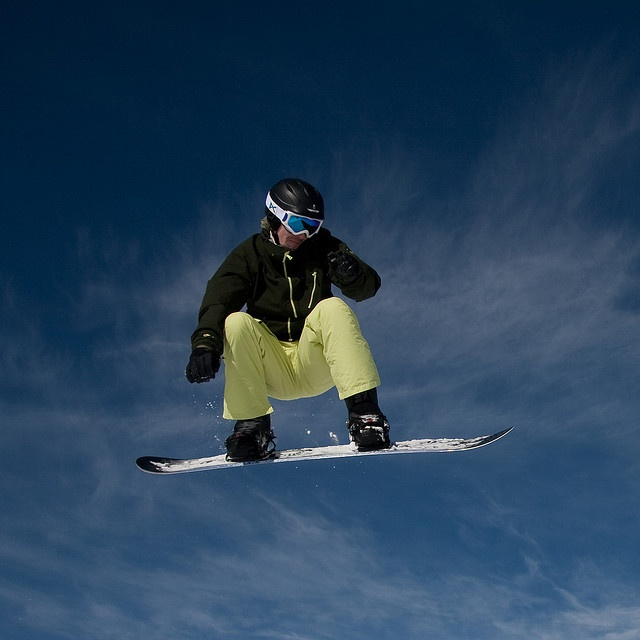Describe the objects in this image and their specific colors. I can see people in black, olive, khaki, and gray tones and snowboard in black, lightgray, darkgray, and gray tones in this image. 